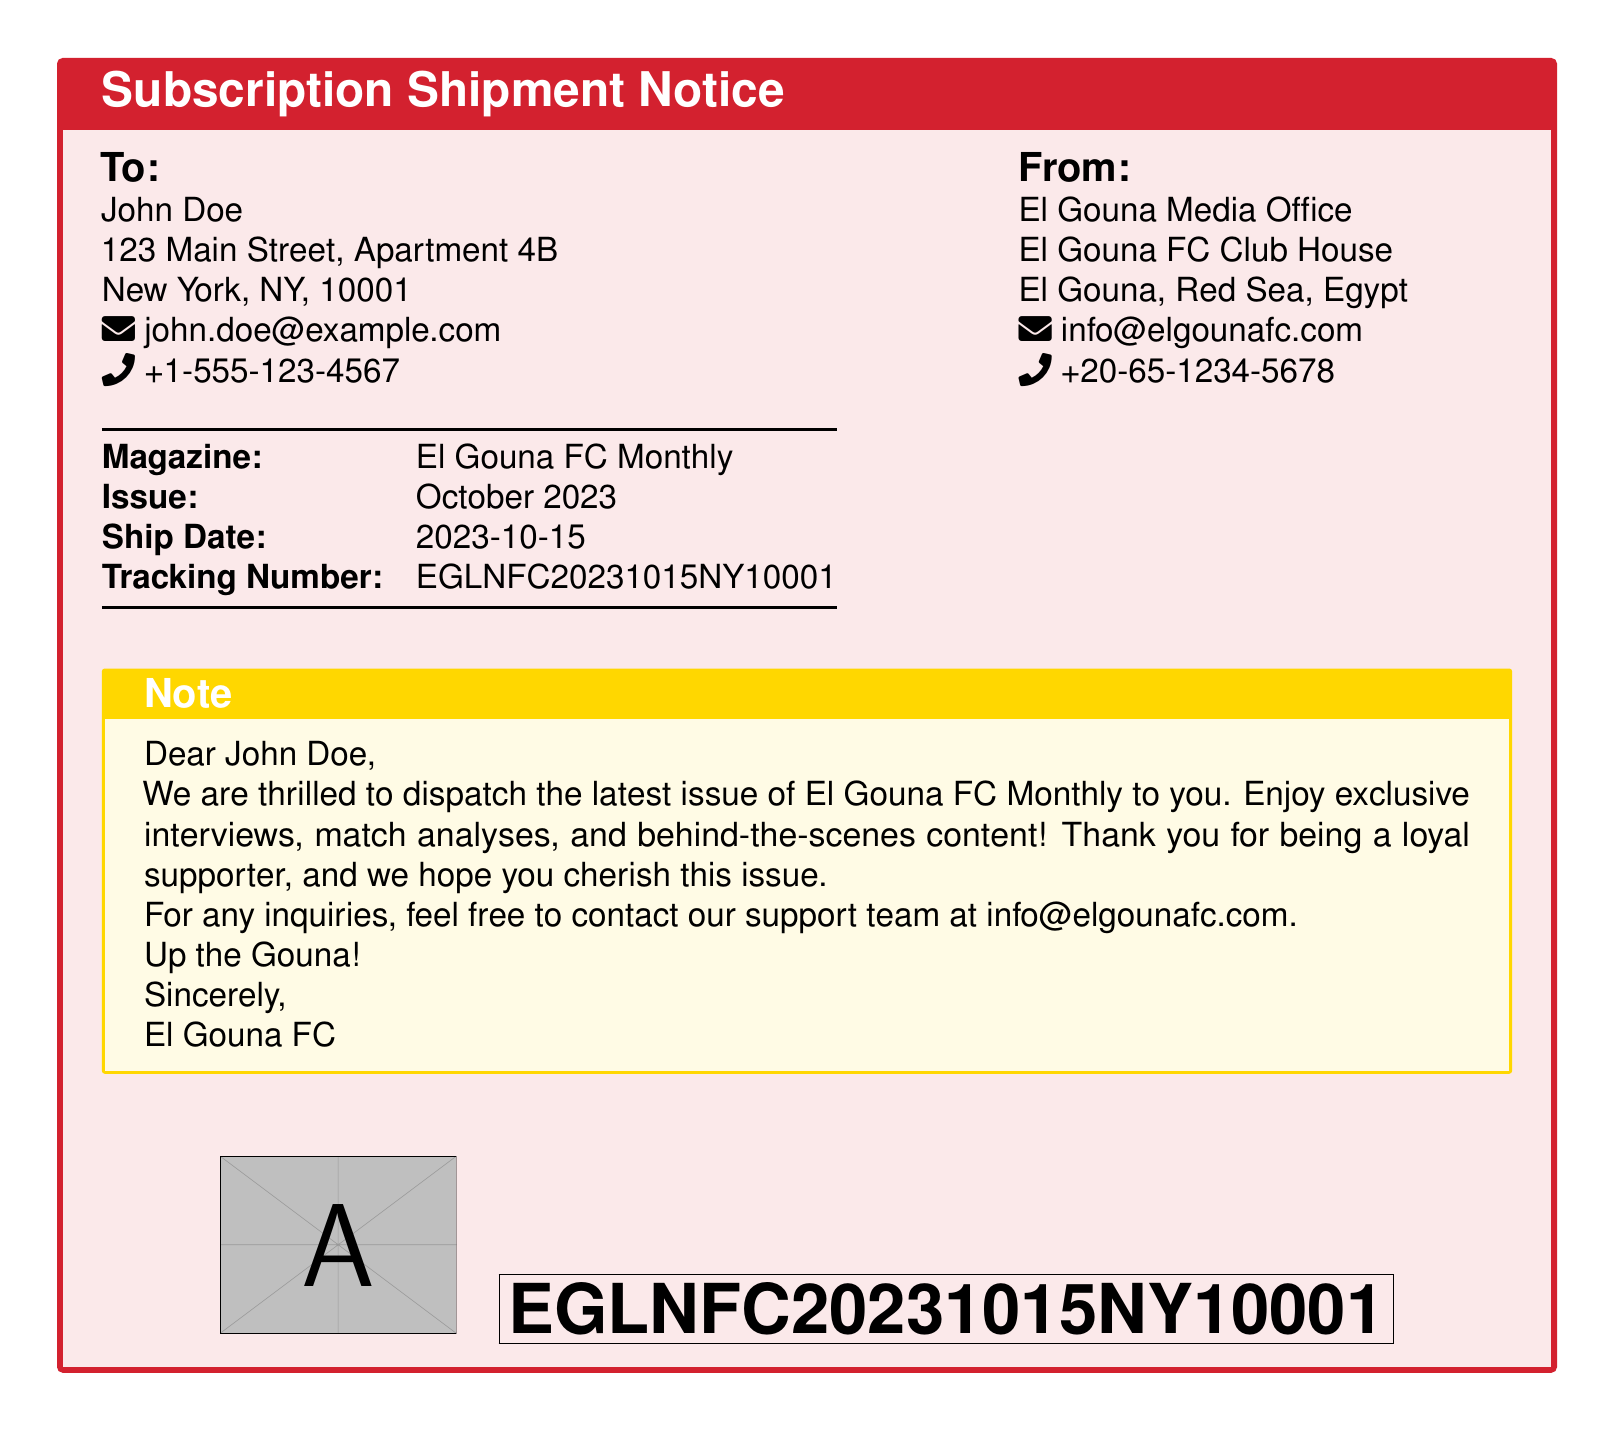What is the magazine's name? The magazine's name is mentioned in the document as "El Gouna FC Monthly."
Answer: El Gouna FC Monthly Who is the recipient of the shipment? The document lists John Doe as the recipient.
Answer: John Doe What is the ship date? The ship date is provided in the document as "2023-10-15."
Answer: 2023-10-15 What is the tracking number? The tracking number is explicitly stated in the document as "EGLNFC20231015NY10001."
Answer: EGLNFC20231015NY10001 Which office is sending the magazine? The sending office is referred to as "El Gouna Media Office."
Answer: El Gouna Media Office What is included in the magazine? The document mentions exclusive interviews, match analyses, and behind-the-scenes content are included.
Answer: Exclusive interviews, match analyses, and behind-the-scenes content Where is El Gouna FC located? The location of El Gouna FC is indicated as "El Gouna, Red Sea, Egypt."
Answer: El Gouna, Red Sea, Egypt What is the color of the subscription notice box? The color of the subscription notice box is "gounaRed."
Answer: gounaRed What is the purpose of the document? The purpose of the document is to inform about the shipment of the magazine.
Answer: Shipment notice 